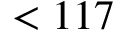Convert formula to latex. <formula><loc_0><loc_0><loc_500><loc_500>< 1 1 7</formula> 